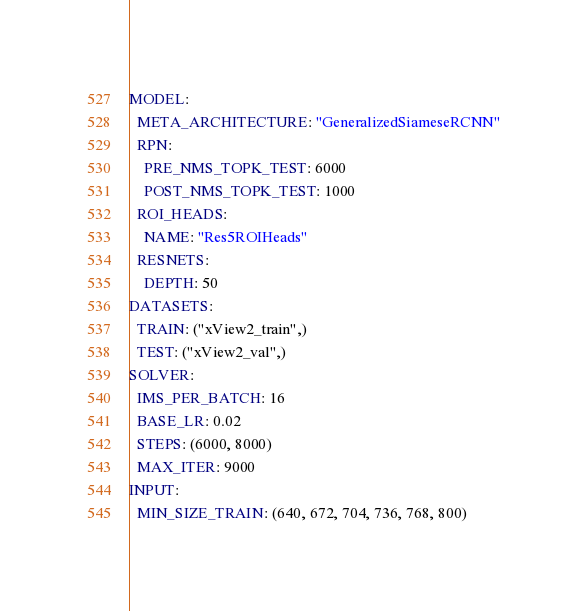Convert code to text. <code><loc_0><loc_0><loc_500><loc_500><_YAML_>MODEL:
  META_ARCHITECTURE: "GeneralizedSiameseRCNN"
  RPN:
    PRE_NMS_TOPK_TEST: 6000
    POST_NMS_TOPK_TEST: 1000
  ROI_HEADS:
    NAME: "Res5ROIHeads"
  RESNETS:
    DEPTH: 50
DATASETS:
  TRAIN: ("xView2_train",)
  TEST: ("xView2_val",)
SOLVER:
  IMS_PER_BATCH: 16
  BASE_LR: 0.02
  STEPS: (6000, 8000)
  MAX_ITER: 9000
INPUT:
  MIN_SIZE_TRAIN: (640, 672, 704, 736, 768, 800)</code> 